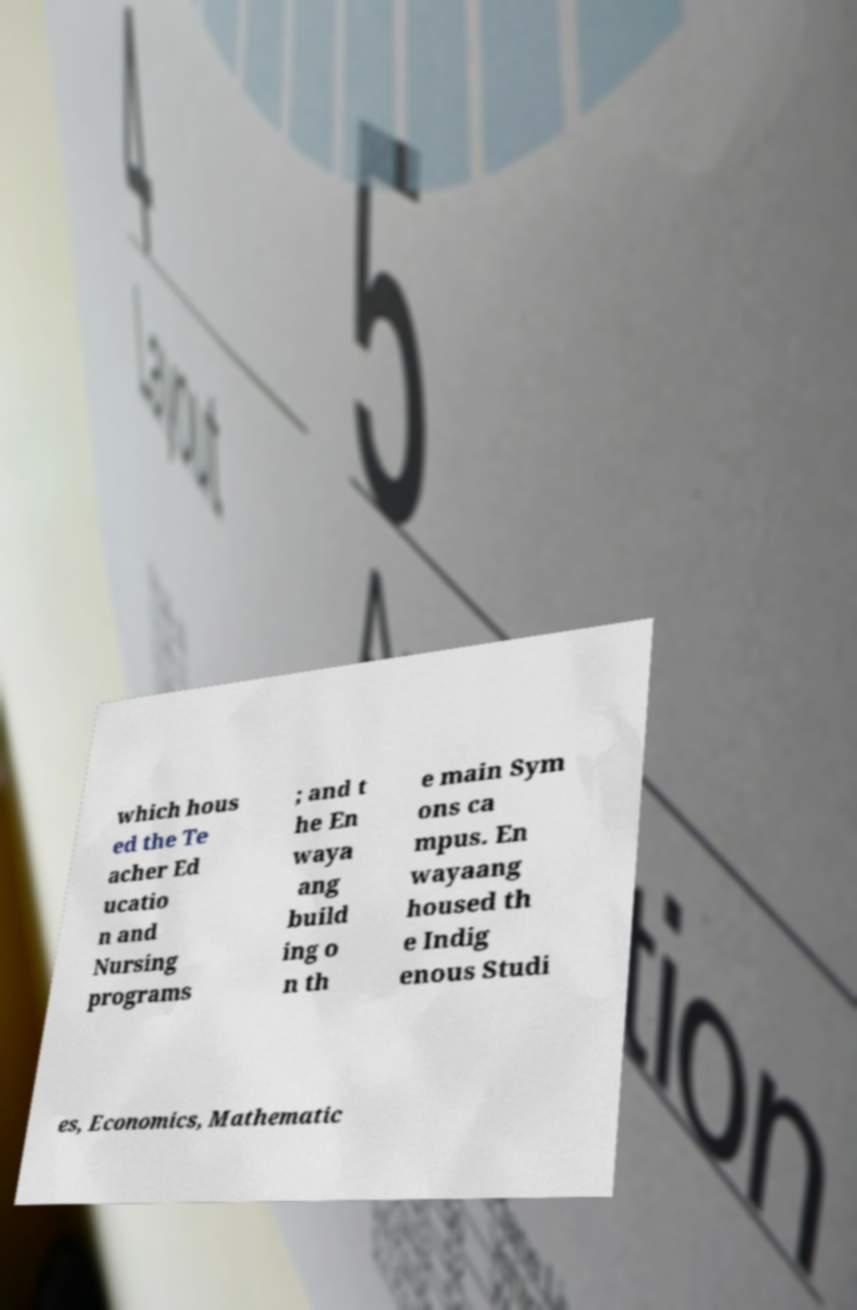Can you read and provide the text displayed in the image?This photo seems to have some interesting text. Can you extract and type it out for me? which hous ed the Te acher Ed ucatio n and Nursing programs ; and t he En waya ang build ing o n th e main Sym ons ca mpus. En wayaang housed th e Indig enous Studi es, Economics, Mathematic 